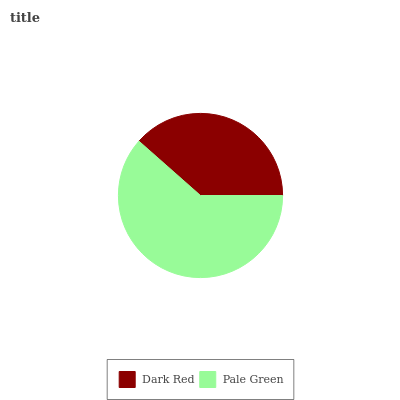Is Dark Red the minimum?
Answer yes or no. Yes. Is Pale Green the maximum?
Answer yes or no. Yes. Is Pale Green the minimum?
Answer yes or no. No. Is Pale Green greater than Dark Red?
Answer yes or no. Yes. Is Dark Red less than Pale Green?
Answer yes or no. Yes. Is Dark Red greater than Pale Green?
Answer yes or no. No. Is Pale Green less than Dark Red?
Answer yes or no. No. Is Pale Green the high median?
Answer yes or no. Yes. Is Dark Red the low median?
Answer yes or no. Yes. Is Dark Red the high median?
Answer yes or no. No. Is Pale Green the low median?
Answer yes or no. No. 